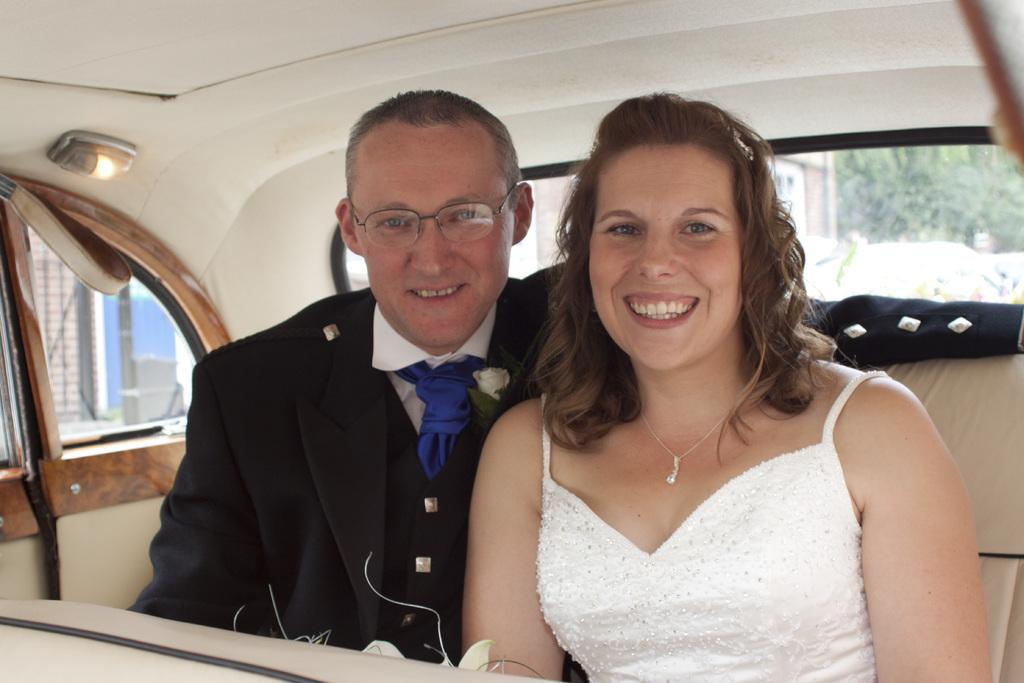How many people are inside the vehicle in the image? There are two persons sitting inside the vehicle. What type of window does the vehicle have? The vehicle has a glass window. Can you describe the lighting in the image? There is light visible in the image. What can be seen outside the vehicle? Trees are visible from the vehicle. What type of ring can be seen on the hands of the persons in the image? There are no hands or rings visible in the image; only the two persons sitting inside the vehicle are present. 